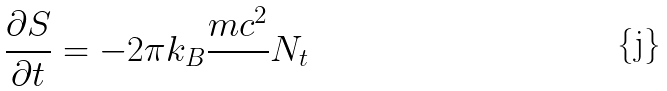Convert formula to latex. <formula><loc_0><loc_0><loc_500><loc_500>\frac { \partial S } { \partial t } = - 2 \pi k _ { B } \frac { m c ^ { 2 } } { } N _ { t }</formula> 